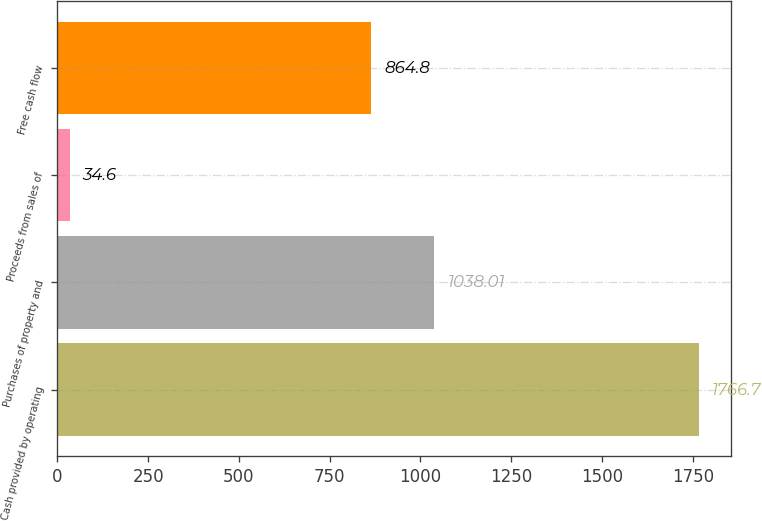Convert chart. <chart><loc_0><loc_0><loc_500><loc_500><bar_chart><fcel>Cash provided by operating<fcel>Purchases of property and<fcel>Proceeds from sales of<fcel>Free cash flow<nl><fcel>1766.7<fcel>1038.01<fcel>34.6<fcel>864.8<nl></chart> 